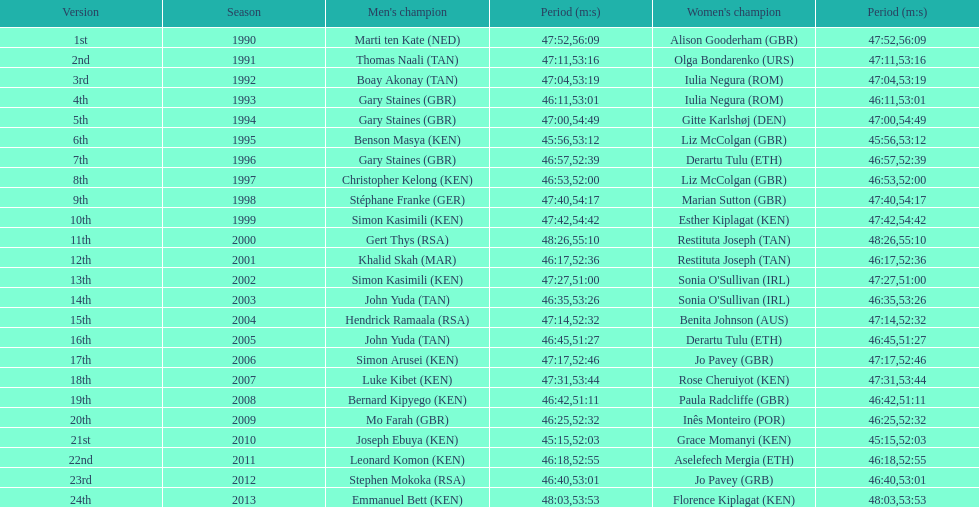Number of men's winners with a finish time under 46:58 12. 